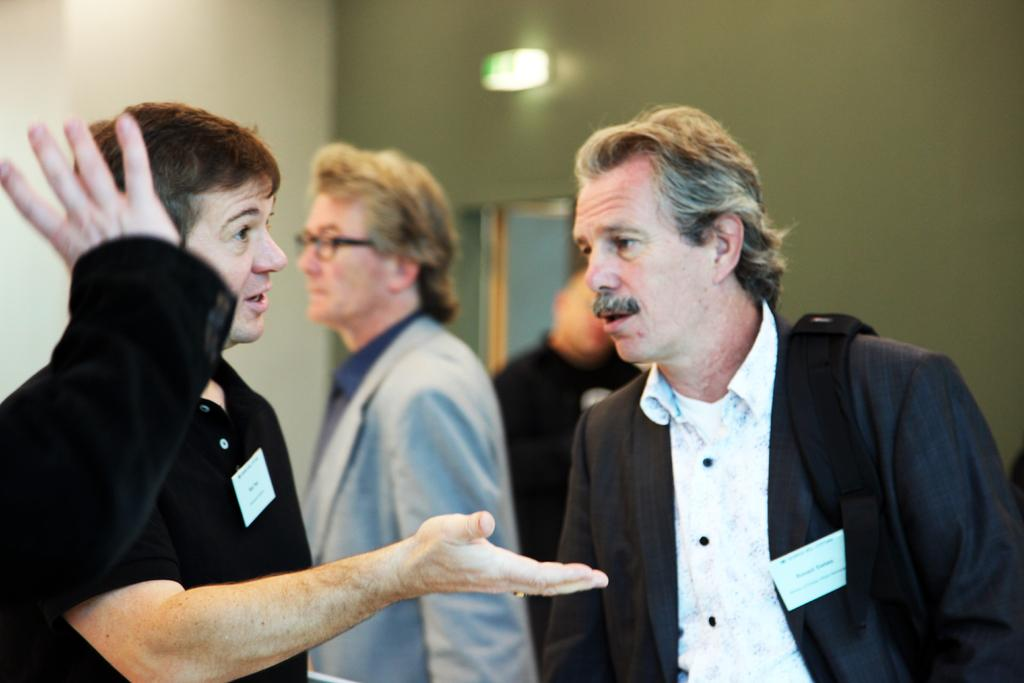How many people are present in the image? There are four persons in the image. What type of structure can be seen in the image? There are walls visible in the image, suggesting it is an indoor setting. Can you describe any architectural features in the image? Yes, there is a door in the image. What is the source of light in the image? There is light in the image, but the specific source is not mentioned. Where is a person's hand located in the image? A person's hand is visible on the left side of the image. What type of pin is being used by the lawyer in the meeting depicted in the image? There is no meeting, lawyer, or pin present in the image. 